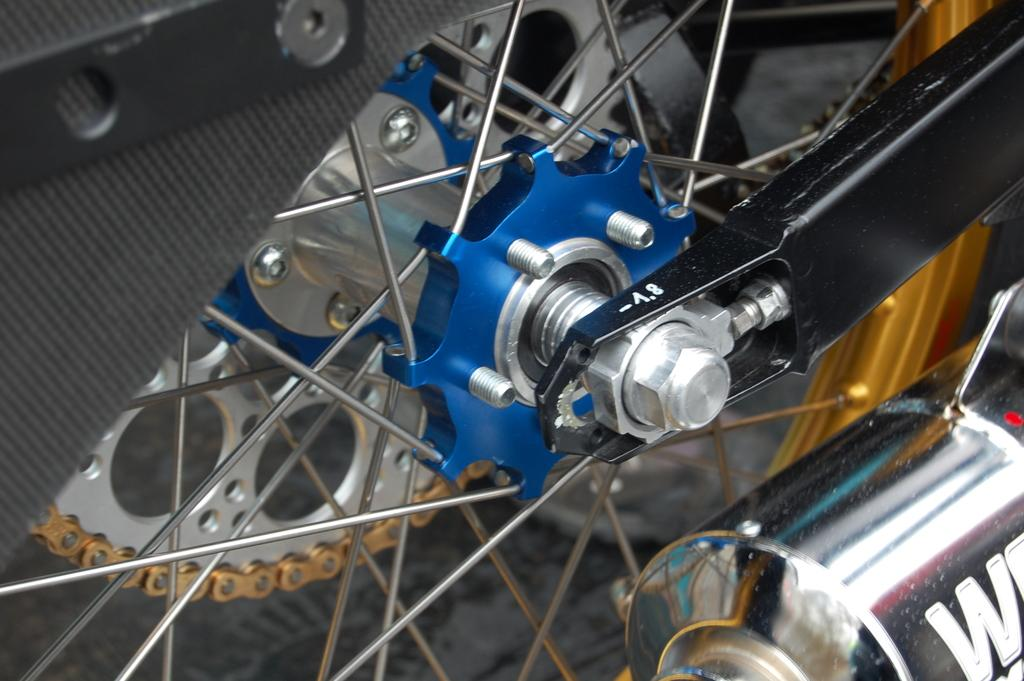What type of vehicle part is visible in the image? There is a motorbike wheel in the image. What other part of a motorbike can be seen in the image? There is a silencer in the image. What type of furniture is present in the image? There is no furniture present in the image; it only features a motorbike wheel and a silencer. What event is taking place in the image? There is no event depicted in the image; it simply shows a motorbike wheel and a silencer. 